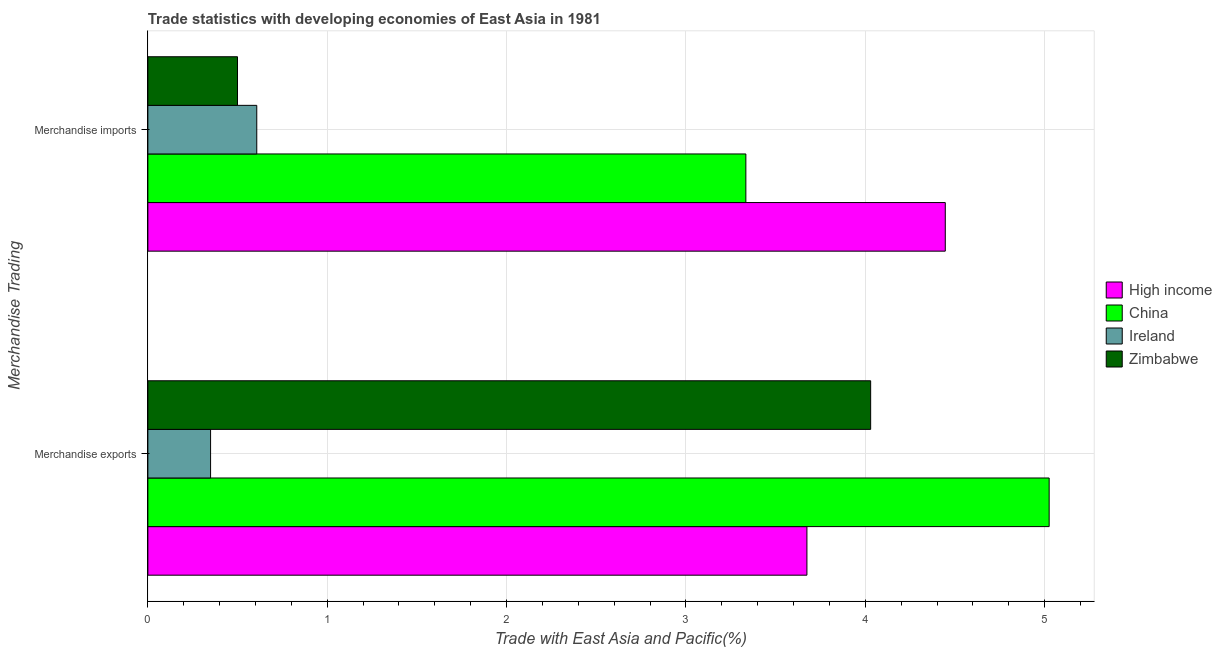How many groups of bars are there?
Provide a short and direct response. 2. Are the number of bars per tick equal to the number of legend labels?
Offer a very short reply. Yes. How many bars are there on the 1st tick from the bottom?
Offer a very short reply. 4. What is the label of the 2nd group of bars from the top?
Provide a succinct answer. Merchandise exports. What is the merchandise imports in Zimbabwe?
Ensure brevity in your answer.  0.5. Across all countries, what is the maximum merchandise imports?
Your answer should be compact. 4.45. Across all countries, what is the minimum merchandise imports?
Provide a succinct answer. 0.5. In which country was the merchandise exports minimum?
Your answer should be compact. Ireland. What is the total merchandise exports in the graph?
Your answer should be very brief. 13.08. What is the difference between the merchandise exports in China and that in Zimbabwe?
Give a very brief answer. 1. What is the difference between the merchandise imports in Ireland and the merchandise exports in Zimbabwe?
Provide a short and direct response. -3.42. What is the average merchandise exports per country?
Ensure brevity in your answer.  3.27. What is the difference between the merchandise imports and merchandise exports in Ireland?
Provide a succinct answer. 0.26. In how many countries, is the merchandise exports greater than 3.8 %?
Offer a terse response. 2. What is the ratio of the merchandise imports in China to that in Zimbabwe?
Provide a succinct answer. 6.67. What does the 3rd bar from the top in Merchandise exports represents?
Provide a succinct answer. China. What does the 3rd bar from the bottom in Merchandise imports represents?
Offer a terse response. Ireland. How many bars are there?
Ensure brevity in your answer.  8. How many countries are there in the graph?
Your answer should be very brief. 4. Are the values on the major ticks of X-axis written in scientific E-notation?
Provide a succinct answer. No. Does the graph contain any zero values?
Your response must be concise. No. Does the graph contain grids?
Offer a very short reply. Yes. How many legend labels are there?
Your answer should be compact. 4. How are the legend labels stacked?
Offer a terse response. Vertical. What is the title of the graph?
Give a very brief answer. Trade statistics with developing economies of East Asia in 1981. What is the label or title of the X-axis?
Give a very brief answer. Trade with East Asia and Pacific(%). What is the label or title of the Y-axis?
Your answer should be compact. Merchandise Trading. What is the Trade with East Asia and Pacific(%) of High income in Merchandise exports?
Your answer should be compact. 3.67. What is the Trade with East Asia and Pacific(%) of China in Merchandise exports?
Your answer should be very brief. 5.03. What is the Trade with East Asia and Pacific(%) in Ireland in Merchandise exports?
Provide a succinct answer. 0.35. What is the Trade with East Asia and Pacific(%) in Zimbabwe in Merchandise exports?
Make the answer very short. 4.03. What is the Trade with East Asia and Pacific(%) of High income in Merchandise imports?
Offer a very short reply. 4.45. What is the Trade with East Asia and Pacific(%) of China in Merchandise imports?
Make the answer very short. 3.33. What is the Trade with East Asia and Pacific(%) of Ireland in Merchandise imports?
Ensure brevity in your answer.  0.61. What is the Trade with East Asia and Pacific(%) in Zimbabwe in Merchandise imports?
Keep it short and to the point. 0.5. Across all Merchandise Trading, what is the maximum Trade with East Asia and Pacific(%) in High income?
Your response must be concise. 4.45. Across all Merchandise Trading, what is the maximum Trade with East Asia and Pacific(%) in China?
Your answer should be very brief. 5.03. Across all Merchandise Trading, what is the maximum Trade with East Asia and Pacific(%) in Ireland?
Make the answer very short. 0.61. Across all Merchandise Trading, what is the maximum Trade with East Asia and Pacific(%) of Zimbabwe?
Give a very brief answer. 4.03. Across all Merchandise Trading, what is the minimum Trade with East Asia and Pacific(%) in High income?
Make the answer very short. 3.67. Across all Merchandise Trading, what is the minimum Trade with East Asia and Pacific(%) in China?
Provide a succinct answer. 3.33. Across all Merchandise Trading, what is the minimum Trade with East Asia and Pacific(%) in Ireland?
Give a very brief answer. 0.35. Across all Merchandise Trading, what is the minimum Trade with East Asia and Pacific(%) in Zimbabwe?
Make the answer very short. 0.5. What is the total Trade with East Asia and Pacific(%) in High income in the graph?
Give a very brief answer. 8.12. What is the total Trade with East Asia and Pacific(%) in China in the graph?
Ensure brevity in your answer.  8.36. What is the total Trade with East Asia and Pacific(%) in Ireland in the graph?
Your answer should be very brief. 0.96. What is the total Trade with East Asia and Pacific(%) of Zimbabwe in the graph?
Your answer should be compact. 4.53. What is the difference between the Trade with East Asia and Pacific(%) of High income in Merchandise exports and that in Merchandise imports?
Your answer should be compact. -0.77. What is the difference between the Trade with East Asia and Pacific(%) in China in Merchandise exports and that in Merchandise imports?
Offer a very short reply. 1.69. What is the difference between the Trade with East Asia and Pacific(%) in Ireland in Merchandise exports and that in Merchandise imports?
Your answer should be very brief. -0.26. What is the difference between the Trade with East Asia and Pacific(%) of Zimbabwe in Merchandise exports and that in Merchandise imports?
Offer a very short reply. 3.53. What is the difference between the Trade with East Asia and Pacific(%) of High income in Merchandise exports and the Trade with East Asia and Pacific(%) of China in Merchandise imports?
Provide a short and direct response. 0.34. What is the difference between the Trade with East Asia and Pacific(%) of High income in Merchandise exports and the Trade with East Asia and Pacific(%) of Ireland in Merchandise imports?
Offer a terse response. 3.07. What is the difference between the Trade with East Asia and Pacific(%) in High income in Merchandise exports and the Trade with East Asia and Pacific(%) in Zimbabwe in Merchandise imports?
Your answer should be compact. 3.17. What is the difference between the Trade with East Asia and Pacific(%) in China in Merchandise exports and the Trade with East Asia and Pacific(%) in Ireland in Merchandise imports?
Provide a succinct answer. 4.42. What is the difference between the Trade with East Asia and Pacific(%) in China in Merchandise exports and the Trade with East Asia and Pacific(%) in Zimbabwe in Merchandise imports?
Provide a succinct answer. 4.53. What is the difference between the Trade with East Asia and Pacific(%) in Ireland in Merchandise exports and the Trade with East Asia and Pacific(%) in Zimbabwe in Merchandise imports?
Keep it short and to the point. -0.15. What is the average Trade with East Asia and Pacific(%) in High income per Merchandise Trading?
Provide a short and direct response. 4.06. What is the average Trade with East Asia and Pacific(%) of China per Merchandise Trading?
Your answer should be compact. 4.18. What is the average Trade with East Asia and Pacific(%) of Ireland per Merchandise Trading?
Keep it short and to the point. 0.48. What is the average Trade with East Asia and Pacific(%) of Zimbabwe per Merchandise Trading?
Give a very brief answer. 2.26. What is the difference between the Trade with East Asia and Pacific(%) in High income and Trade with East Asia and Pacific(%) in China in Merchandise exports?
Ensure brevity in your answer.  -1.35. What is the difference between the Trade with East Asia and Pacific(%) of High income and Trade with East Asia and Pacific(%) of Ireland in Merchandise exports?
Your answer should be compact. 3.33. What is the difference between the Trade with East Asia and Pacific(%) of High income and Trade with East Asia and Pacific(%) of Zimbabwe in Merchandise exports?
Your answer should be compact. -0.36. What is the difference between the Trade with East Asia and Pacific(%) in China and Trade with East Asia and Pacific(%) in Ireland in Merchandise exports?
Your response must be concise. 4.68. What is the difference between the Trade with East Asia and Pacific(%) in Ireland and Trade with East Asia and Pacific(%) in Zimbabwe in Merchandise exports?
Keep it short and to the point. -3.68. What is the difference between the Trade with East Asia and Pacific(%) in High income and Trade with East Asia and Pacific(%) in China in Merchandise imports?
Provide a succinct answer. 1.11. What is the difference between the Trade with East Asia and Pacific(%) in High income and Trade with East Asia and Pacific(%) in Ireland in Merchandise imports?
Your response must be concise. 3.84. What is the difference between the Trade with East Asia and Pacific(%) of High income and Trade with East Asia and Pacific(%) of Zimbabwe in Merchandise imports?
Provide a short and direct response. 3.95. What is the difference between the Trade with East Asia and Pacific(%) in China and Trade with East Asia and Pacific(%) in Ireland in Merchandise imports?
Keep it short and to the point. 2.73. What is the difference between the Trade with East Asia and Pacific(%) of China and Trade with East Asia and Pacific(%) of Zimbabwe in Merchandise imports?
Your answer should be very brief. 2.83. What is the difference between the Trade with East Asia and Pacific(%) in Ireland and Trade with East Asia and Pacific(%) in Zimbabwe in Merchandise imports?
Ensure brevity in your answer.  0.11. What is the ratio of the Trade with East Asia and Pacific(%) of High income in Merchandise exports to that in Merchandise imports?
Your answer should be very brief. 0.83. What is the ratio of the Trade with East Asia and Pacific(%) in China in Merchandise exports to that in Merchandise imports?
Provide a short and direct response. 1.51. What is the ratio of the Trade with East Asia and Pacific(%) in Ireland in Merchandise exports to that in Merchandise imports?
Provide a succinct answer. 0.58. What is the ratio of the Trade with East Asia and Pacific(%) in Zimbabwe in Merchandise exports to that in Merchandise imports?
Provide a succinct answer. 8.06. What is the difference between the highest and the second highest Trade with East Asia and Pacific(%) of High income?
Make the answer very short. 0.77. What is the difference between the highest and the second highest Trade with East Asia and Pacific(%) of China?
Provide a short and direct response. 1.69. What is the difference between the highest and the second highest Trade with East Asia and Pacific(%) in Ireland?
Provide a succinct answer. 0.26. What is the difference between the highest and the second highest Trade with East Asia and Pacific(%) of Zimbabwe?
Give a very brief answer. 3.53. What is the difference between the highest and the lowest Trade with East Asia and Pacific(%) in High income?
Offer a terse response. 0.77. What is the difference between the highest and the lowest Trade with East Asia and Pacific(%) of China?
Keep it short and to the point. 1.69. What is the difference between the highest and the lowest Trade with East Asia and Pacific(%) of Ireland?
Your response must be concise. 0.26. What is the difference between the highest and the lowest Trade with East Asia and Pacific(%) in Zimbabwe?
Provide a succinct answer. 3.53. 